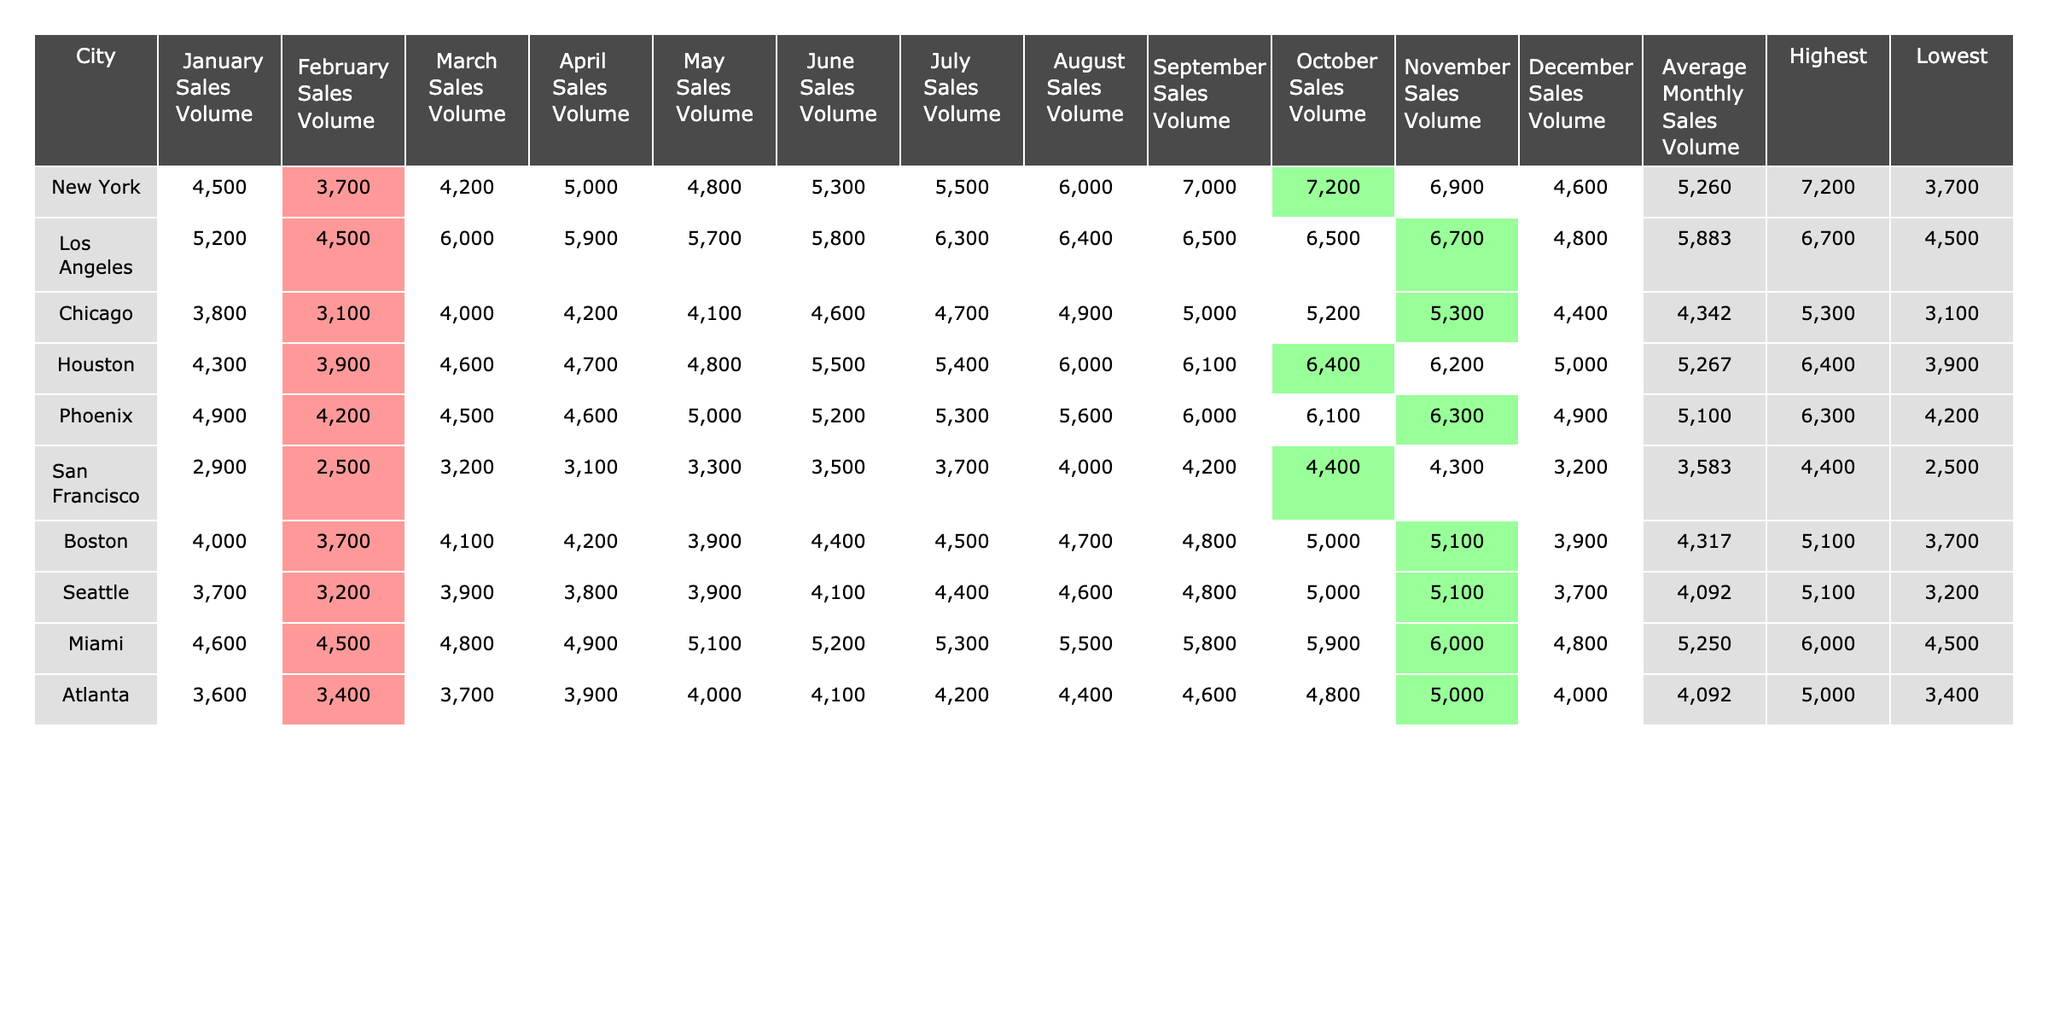What was the highest sales volume recorded in New York in 2023? The table shows the monthly sales volume for New York, and the highest value listed is 7200, which occurs in October.
Answer: 7200 Which city had the lowest average monthly sales volume? To find the lowest average, we compare all average monthly sales volume values. Chicago has the lowest average at 4342.
Answer: Chicago What’s the total sales volume for Los Angeles from January to December? By summing the monthly values for Los Angeles, we get: 5200 + 4500 + 6000 + 5900 + 5700 + 5800 + 6300 + 6400 + 6500 + 6500 + 6700 + 4800 = 68200.
Answer: 68200 Did Miami ever have a monthly sales volume lower than 4600? Checking the data for Miami's sales volume, all months are above 4600, so the answer is no.
Answer: No What is the difference between the highest and lowest sales volume for Houston? The highest sales volume for Houston is 6400 and the lowest is 3900. Calculating the difference gives us 6400 - 3900 = 2500.
Answer: 2500 In which month did Seattle have its highest sales volume, and what was that value? From the data, Seattle's highest sales volume is 5100, which occurs in November.
Answer: November, 5100 What is the average sales volume for San Francisco across all months? The table states that the average monthly sales volume for San Francisco is 3583, calculated by summing its monthly figures and dividing by 12.
Answer: 3583 Which city had a consistent increase in sales volume from January to July? By examining the data, it shows that Los Angeles had increasing values from January (5200) to July (6300).
Answer: Los Angeles Is the average monthly sales volume for New York above 5000? The average for New York is 5260, which is indeed above 5000, confirming the fact is true.
Answer: Yes What was the sales volume trend for Chicago from April to December? Reviewing the values for Chicago from April (4200) to December (4400), we see slight increases towards a final value of 4400.
Answer: Increasing trend 